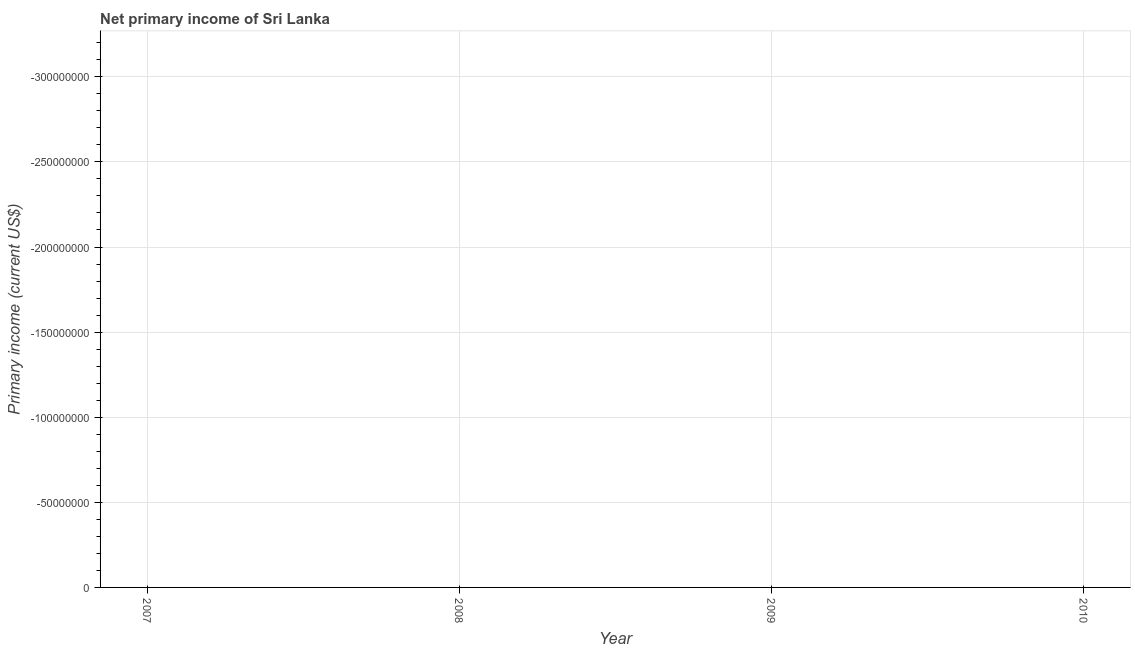What is the amount of primary income in 2009?
Keep it short and to the point. 0. What is the sum of the amount of primary income?
Ensure brevity in your answer.  0. What is the average amount of primary income per year?
Make the answer very short. 0. Are the values on the major ticks of Y-axis written in scientific E-notation?
Make the answer very short. No. Does the graph contain any zero values?
Ensure brevity in your answer.  Yes. Does the graph contain grids?
Keep it short and to the point. Yes. What is the title of the graph?
Give a very brief answer. Net primary income of Sri Lanka. What is the label or title of the Y-axis?
Your answer should be very brief. Primary income (current US$). What is the Primary income (current US$) in 2007?
Offer a terse response. 0. What is the Primary income (current US$) in 2008?
Provide a succinct answer. 0. 